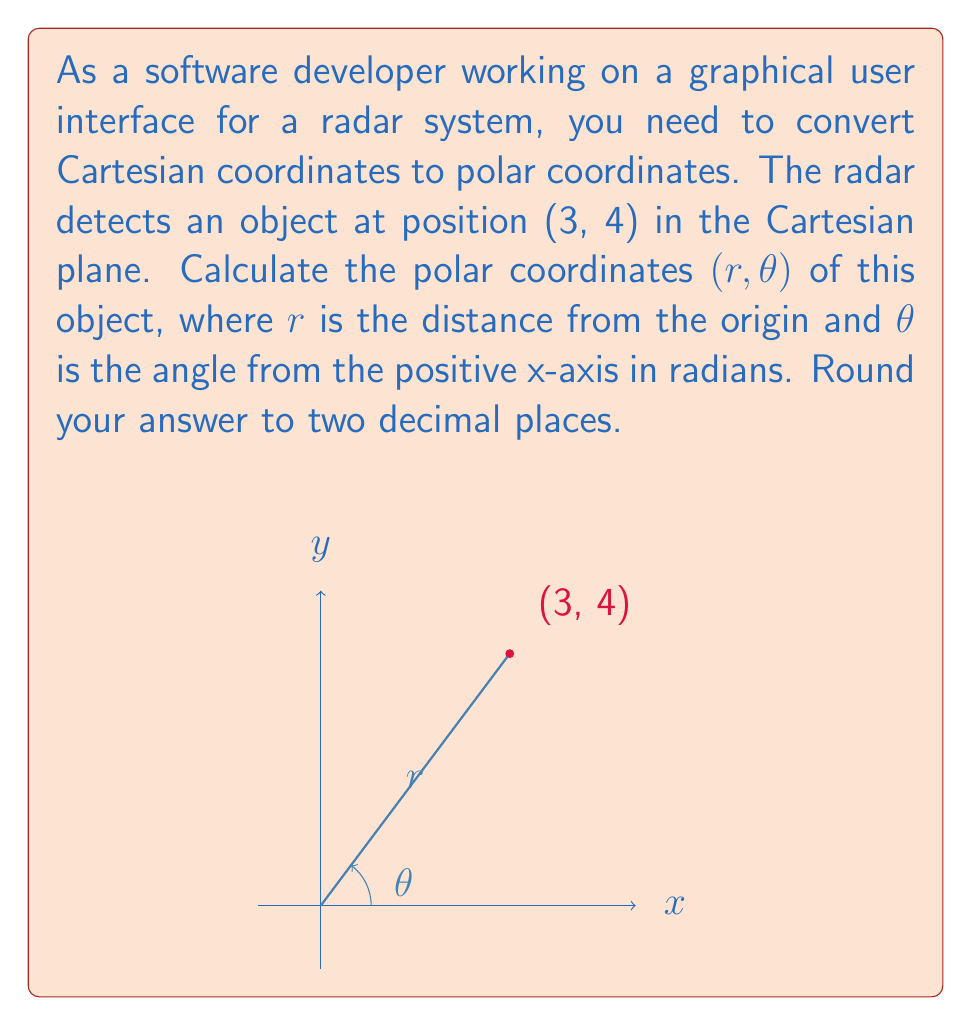Can you solve this math problem? To convert from Cartesian coordinates (x, y) to polar coordinates (r, θ), we use the following formulas:

1. $r = \sqrt{x^2 + y^2}$
2. $\theta = \tan^{-1}(\frac{y}{x})$

Given the Cartesian coordinates (3, 4), let's solve step by step:

1. Calculate r:
   $$r = \sqrt{3^2 + 4^2} = \sqrt{9 + 16} = \sqrt{25} = 5$$

2. Calculate θ:
   $$\theta = \tan^{-1}(\frac{4}{3}) \approx 0.9272952180$$

3. Convert θ to radians (it's already in radians, so no conversion needed)

4. Round both values to two decimal places:
   r ≈ 5.00
   θ ≈ 0.93 radians

Therefore, the polar coordinates are approximately (5.00, 0.93).
Answer: (5.00, 0.93) 